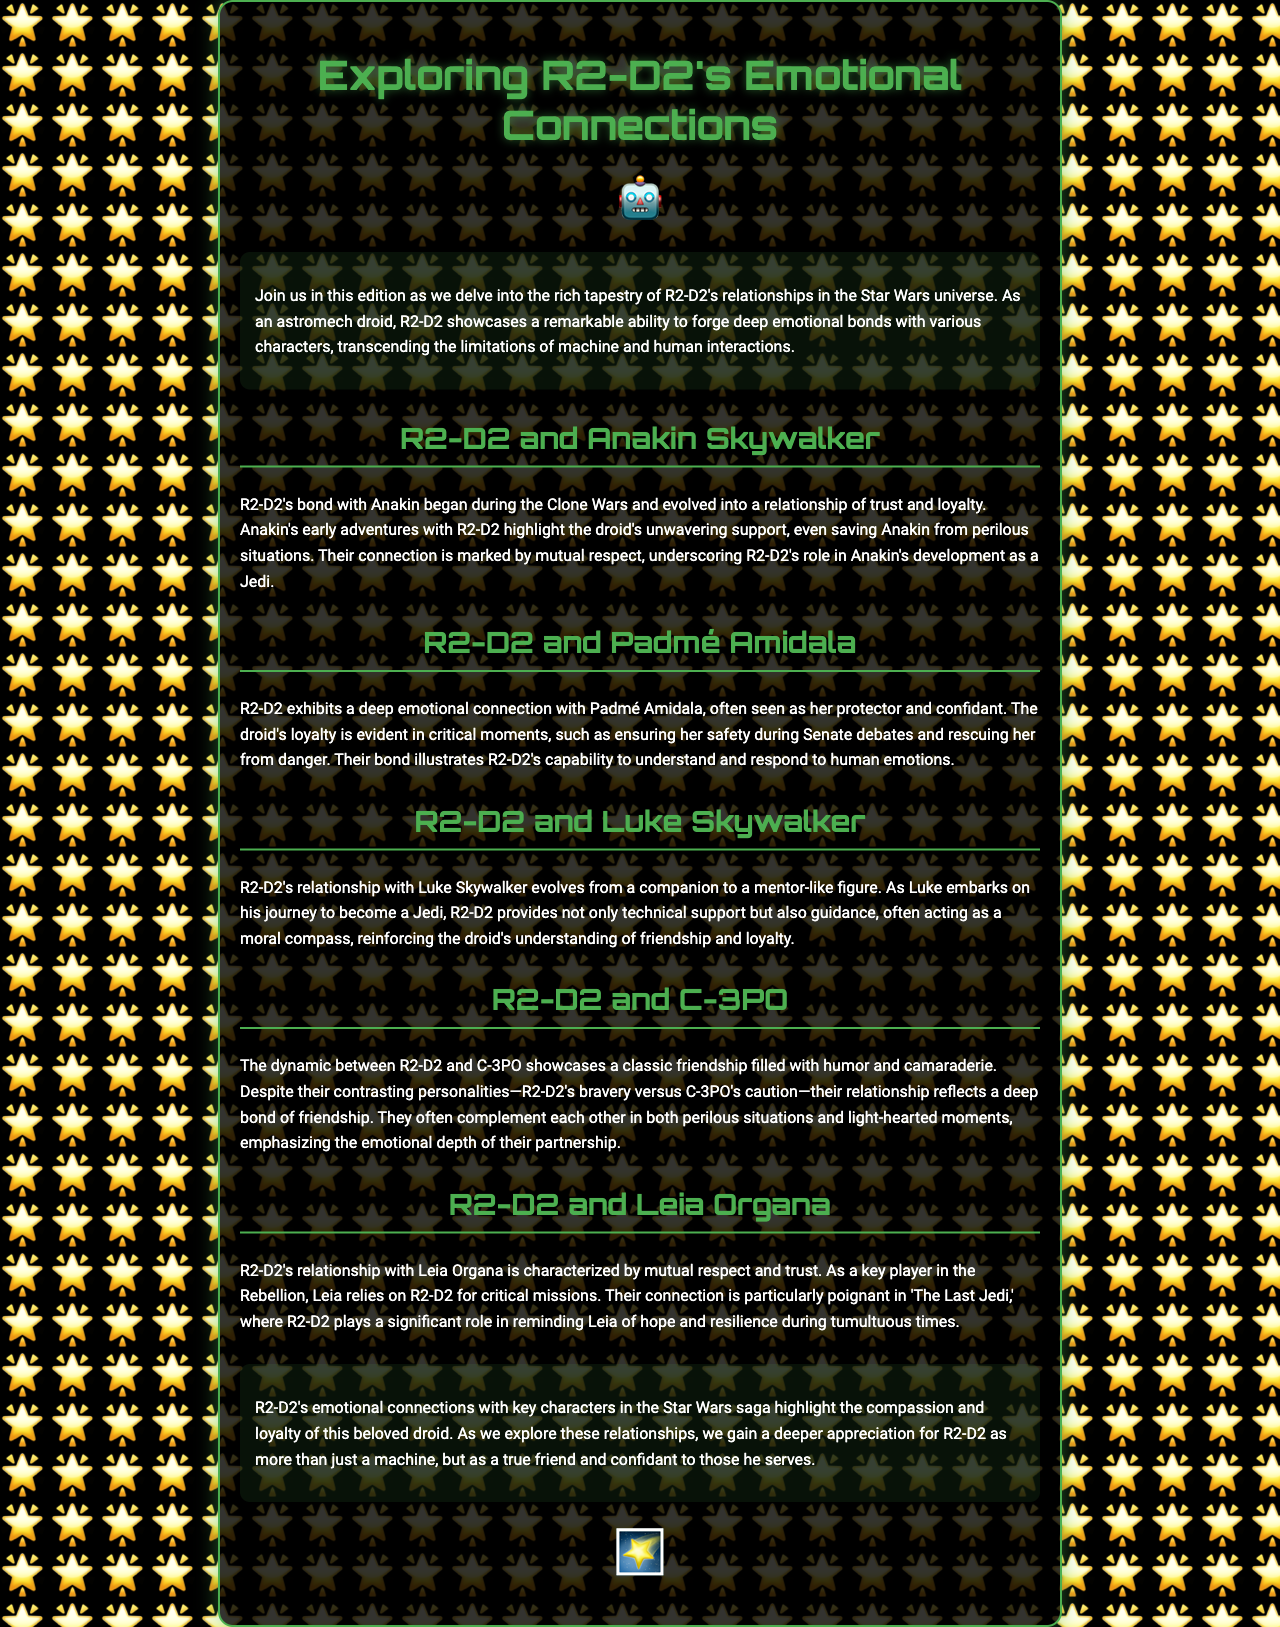what is the title of the newsletter? The title is prominently featured at the top of the document, which is "Exploring R2-D2's Emotional Connections."
Answer: Exploring R2-D2's Emotional Connections who is R2-D2's companion that contrasts his bravery? The document mentions C-3PO as R2-D2's companion, contrasting R2-D2's bravery with C-3PO's caution.
Answer: C-3PO which character does R2-D2 serve as a protector and confidant? The document states that R2-D2 exhibits a deep emotional connection with Padmé Amidala, serving as her protector and confidant.
Answer: Padmé Amidala how does R2-D2's relationship with Luke Skywalker evolve? The relationship evolves from a companion to a mentor-like figure, providing support and guidance during Luke's journey to become a Jedi.
Answer: Mentor-like figure what role does R2-D2 play in 'The Last Jedi' with respect to Leia Organa? In 'The Last Jedi,' R2-D2 plays a significant role in reminding Leia of hope and resilience during tumultuous times.
Answer: Reminding of hope and resilience which two characters are highlighted for their friendship filled with humor? The document specifically highlights the friendship filled with humor between R2-D2 and C-3PO.
Answer: R2-D2 and C-3PO what significant theme is emphasized in R2-D2's relationships throughout the document? The significant theme emphasized is compassion and loyalty, showcasing R2-D2's emotional connections.
Answer: Compassion and loyalty in what context does R2-D2 provide critical support to Leia Organa? R2-D2 provides critical support to Leia Organa during key missions integral to the Rebellion.
Answer: Key missions 